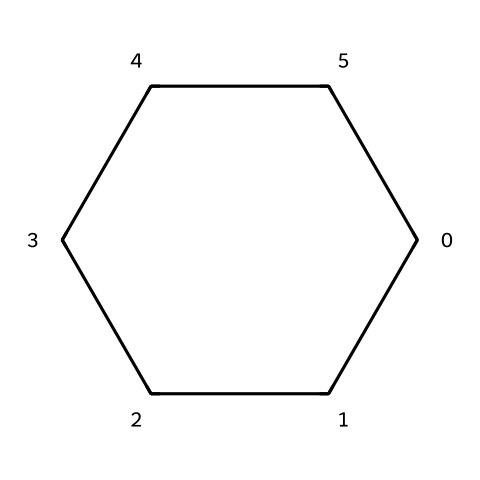What is the molecular formula of cyclohexane? To determine the molecular formula, we can count the number of carbon (C) and hydrogen (H) atoms in the structure. There are 6 carbon atoms and 12 hydrogen atoms. The molecular formula is thus C6H12.
Answer: C6H12 How many carbon atoms are in cyclohexane? The chemical structure of cyclohexane shows a ring made up of 6 carbon atoms. We can visually identify this from the cyclical arrangement depicted in the SMILES string.
Answer: 6 What type of structure does cyclohexane have? Cyclohexane has a cyclic structure, specifically a cycloalkane, meaning it has a closed loop of carbon atoms. It is identifiable as a carbon ring from its SMILES representation.
Answer: cyclic How many hydrogen atoms are attached to each carbon in cyclohexane? In cyclohexane, each carbon atom is bonded to two other carbon atoms and two hydrogen atoms, following the tetravalence of carbon. Therefore, each carbon in this structure is attached to two hydrogen atoms.
Answer: 2 What is the degree of saturation of cyclohexane? The degree of saturation refers to the number of hydrogen atoms a compound can have, relative to the number of carbon atoms. Cyclohexane has a saturated structure with no double or triple bonds, showing it has the maximum number of hydrogens for its carbon count.
Answer: saturated Is cyclohexane polar or nonpolar? Cyclohexane consists only of carbon and hydrogen atoms, and because it has a symmetrical structure without any electronegative atoms, it is classified as nonpolar.
Answer: nonpolar What type of chemical is cyclohexane classified as? Cyclohexane falls under the category of cycloalkanes, which are aliphatic hydrocarbons formed in a ring structure. The presence of the saturated carbon ring indicates its classification.
Answer: cycloalkane 